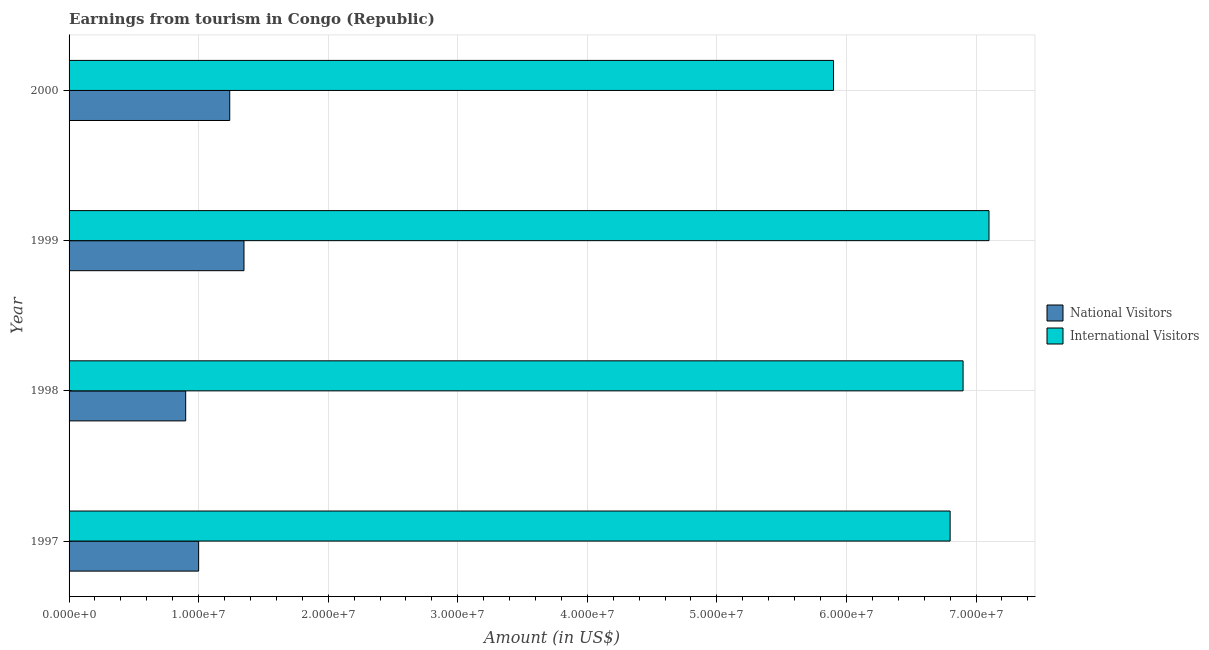How many different coloured bars are there?
Your answer should be compact. 2. How many groups of bars are there?
Give a very brief answer. 4. Are the number of bars per tick equal to the number of legend labels?
Make the answer very short. Yes. How many bars are there on the 3rd tick from the top?
Provide a succinct answer. 2. How many bars are there on the 2nd tick from the bottom?
Your answer should be very brief. 2. What is the label of the 1st group of bars from the top?
Ensure brevity in your answer.  2000. In how many cases, is the number of bars for a given year not equal to the number of legend labels?
Your answer should be compact. 0. What is the amount earned from international visitors in 1997?
Your answer should be compact. 6.80e+07. Across all years, what is the maximum amount earned from national visitors?
Provide a succinct answer. 1.35e+07. Across all years, what is the minimum amount earned from international visitors?
Make the answer very short. 5.90e+07. In which year was the amount earned from national visitors maximum?
Make the answer very short. 1999. What is the total amount earned from international visitors in the graph?
Give a very brief answer. 2.67e+08. What is the difference between the amount earned from international visitors in 1997 and that in 2000?
Give a very brief answer. 9.00e+06. What is the difference between the amount earned from national visitors in 1999 and the amount earned from international visitors in 1998?
Ensure brevity in your answer.  -5.55e+07. What is the average amount earned from national visitors per year?
Your answer should be compact. 1.12e+07. In the year 1999, what is the difference between the amount earned from national visitors and amount earned from international visitors?
Offer a terse response. -5.75e+07. What is the ratio of the amount earned from national visitors in 1998 to that in 1999?
Your answer should be very brief. 0.67. Is the difference between the amount earned from national visitors in 1998 and 1999 greater than the difference between the amount earned from international visitors in 1998 and 1999?
Your answer should be very brief. No. What is the difference between the highest and the second highest amount earned from national visitors?
Your response must be concise. 1.10e+06. What is the difference between the highest and the lowest amount earned from international visitors?
Your answer should be very brief. 1.20e+07. What does the 2nd bar from the top in 1998 represents?
Ensure brevity in your answer.  National Visitors. What does the 1st bar from the bottom in 1999 represents?
Offer a terse response. National Visitors. How many bars are there?
Ensure brevity in your answer.  8. How many years are there in the graph?
Provide a short and direct response. 4. Are the values on the major ticks of X-axis written in scientific E-notation?
Provide a succinct answer. Yes. Does the graph contain any zero values?
Make the answer very short. No. Does the graph contain grids?
Offer a terse response. Yes. Where does the legend appear in the graph?
Offer a terse response. Center right. How are the legend labels stacked?
Your response must be concise. Vertical. What is the title of the graph?
Your answer should be very brief. Earnings from tourism in Congo (Republic). Does "Lowest 10% of population" appear as one of the legend labels in the graph?
Offer a terse response. No. What is the label or title of the X-axis?
Provide a short and direct response. Amount (in US$). What is the label or title of the Y-axis?
Ensure brevity in your answer.  Year. What is the Amount (in US$) of National Visitors in 1997?
Give a very brief answer. 1.00e+07. What is the Amount (in US$) in International Visitors in 1997?
Provide a short and direct response. 6.80e+07. What is the Amount (in US$) in National Visitors in 1998?
Offer a very short reply. 9.00e+06. What is the Amount (in US$) in International Visitors in 1998?
Your answer should be very brief. 6.90e+07. What is the Amount (in US$) in National Visitors in 1999?
Make the answer very short. 1.35e+07. What is the Amount (in US$) of International Visitors in 1999?
Keep it short and to the point. 7.10e+07. What is the Amount (in US$) in National Visitors in 2000?
Offer a very short reply. 1.24e+07. What is the Amount (in US$) in International Visitors in 2000?
Offer a terse response. 5.90e+07. Across all years, what is the maximum Amount (in US$) of National Visitors?
Make the answer very short. 1.35e+07. Across all years, what is the maximum Amount (in US$) of International Visitors?
Provide a succinct answer. 7.10e+07. Across all years, what is the minimum Amount (in US$) of National Visitors?
Your answer should be very brief. 9.00e+06. Across all years, what is the minimum Amount (in US$) of International Visitors?
Keep it short and to the point. 5.90e+07. What is the total Amount (in US$) of National Visitors in the graph?
Make the answer very short. 4.49e+07. What is the total Amount (in US$) in International Visitors in the graph?
Provide a short and direct response. 2.67e+08. What is the difference between the Amount (in US$) in National Visitors in 1997 and that in 1998?
Give a very brief answer. 1.00e+06. What is the difference between the Amount (in US$) of International Visitors in 1997 and that in 1998?
Ensure brevity in your answer.  -1.00e+06. What is the difference between the Amount (in US$) of National Visitors in 1997 and that in 1999?
Your answer should be compact. -3.50e+06. What is the difference between the Amount (in US$) of International Visitors in 1997 and that in 1999?
Your answer should be compact. -3.00e+06. What is the difference between the Amount (in US$) of National Visitors in 1997 and that in 2000?
Provide a succinct answer. -2.40e+06. What is the difference between the Amount (in US$) in International Visitors in 1997 and that in 2000?
Provide a succinct answer. 9.00e+06. What is the difference between the Amount (in US$) of National Visitors in 1998 and that in 1999?
Provide a succinct answer. -4.50e+06. What is the difference between the Amount (in US$) in International Visitors in 1998 and that in 1999?
Give a very brief answer. -2.00e+06. What is the difference between the Amount (in US$) in National Visitors in 1998 and that in 2000?
Offer a very short reply. -3.40e+06. What is the difference between the Amount (in US$) in National Visitors in 1999 and that in 2000?
Your answer should be compact. 1.10e+06. What is the difference between the Amount (in US$) in International Visitors in 1999 and that in 2000?
Your response must be concise. 1.20e+07. What is the difference between the Amount (in US$) of National Visitors in 1997 and the Amount (in US$) of International Visitors in 1998?
Your response must be concise. -5.90e+07. What is the difference between the Amount (in US$) of National Visitors in 1997 and the Amount (in US$) of International Visitors in 1999?
Make the answer very short. -6.10e+07. What is the difference between the Amount (in US$) of National Visitors in 1997 and the Amount (in US$) of International Visitors in 2000?
Give a very brief answer. -4.90e+07. What is the difference between the Amount (in US$) of National Visitors in 1998 and the Amount (in US$) of International Visitors in 1999?
Your answer should be very brief. -6.20e+07. What is the difference between the Amount (in US$) in National Visitors in 1998 and the Amount (in US$) in International Visitors in 2000?
Give a very brief answer. -5.00e+07. What is the difference between the Amount (in US$) of National Visitors in 1999 and the Amount (in US$) of International Visitors in 2000?
Keep it short and to the point. -4.55e+07. What is the average Amount (in US$) of National Visitors per year?
Your response must be concise. 1.12e+07. What is the average Amount (in US$) of International Visitors per year?
Your response must be concise. 6.68e+07. In the year 1997, what is the difference between the Amount (in US$) in National Visitors and Amount (in US$) in International Visitors?
Your answer should be very brief. -5.80e+07. In the year 1998, what is the difference between the Amount (in US$) of National Visitors and Amount (in US$) of International Visitors?
Give a very brief answer. -6.00e+07. In the year 1999, what is the difference between the Amount (in US$) of National Visitors and Amount (in US$) of International Visitors?
Keep it short and to the point. -5.75e+07. In the year 2000, what is the difference between the Amount (in US$) of National Visitors and Amount (in US$) of International Visitors?
Your answer should be very brief. -4.66e+07. What is the ratio of the Amount (in US$) in International Visitors in 1997 to that in 1998?
Give a very brief answer. 0.99. What is the ratio of the Amount (in US$) of National Visitors in 1997 to that in 1999?
Offer a very short reply. 0.74. What is the ratio of the Amount (in US$) of International Visitors in 1997 to that in 1999?
Your response must be concise. 0.96. What is the ratio of the Amount (in US$) in National Visitors in 1997 to that in 2000?
Offer a terse response. 0.81. What is the ratio of the Amount (in US$) of International Visitors in 1997 to that in 2000?
Offer a very short reply. 1.15. What is the ratio of the Amount (in US$) of National Visitors in 1998 to that in 1999?
Keep it short and to the point. 0.67. What is the ratio of the Amount (in US$) of International Visitors in 1998 to that in 1999?
Provide a succinct answer. 0.97. What is the ratio of the Amount (in US$) in National Visitors in 1998 to that in 2000?
Your response must be concise. 0.73. What is the ratio of the Amount (in US$) in International Visitors in 1998 to that in 2000?
Make the answer very short. 1.17. What is the ratio of the Amount (in US$) in National Visitors in 1999 to that in 2000?
Keep it short and to the point. 1.09. What is the ratio of the Amount (in US$) in International Visitors in 1999 to that in 2000?
Provide a short and direct response. 1.2. What is the difference between the highest and the second highest Amount (in US$) of National Visitors?
Make the answer very short. 1.10e+06. What is the difference between the highest and the second highest Amount (in US$) of International Visitors?
Your answer should be compact. 2.00e+06. What is the difference between the highest and the lowest Amount (in US$) in National Visitors?
Make the answer very short. 4.50e+06. What is the difference between the highest and the lowest Amount (in US$) in International Visitors?
Keep it short and to the point. 1.20e+07. 